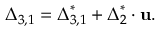Convert formula to latex. <formula><loc_0><loc_0><loc_500><loc_500>{ { \Delta } _ { 3 , 1 } } = { \Delta } _ { 3 , 1 } ^ { * } + { \Delta } _ { 2 } ^ { * } \cdot { u } .</formula> 